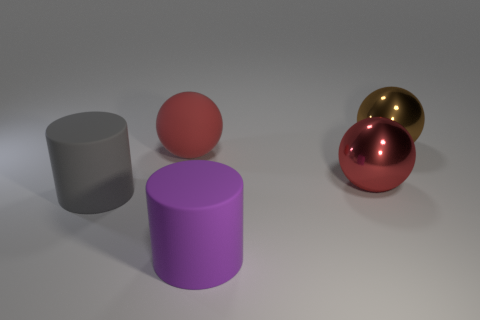Can you describe the lighting and shadows visible in the image? The lighting in the image appears to be coming from the upper left, as indicated by the shadows cast towards the lower right. The shadows are soft-edged, suggesting a diffused light source, which gives the scene a calm and even tone. 